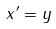<formula> <loc_0><loc_0><loc_500><loc_500>x ^ { \prime } = y</formula> 